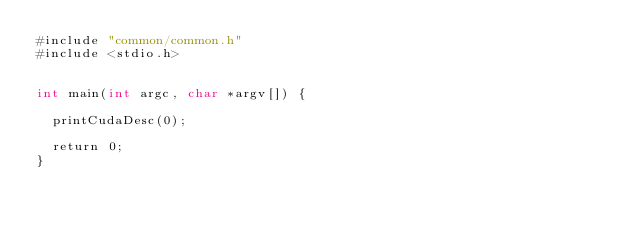Convert code to text. <code><loc_0><loc_0><loc_500><loc_500><_Cuda_>#include "common/common.h"
#include <stdio.h>


int main(int argc, char *argv[]) {

  printCudaDesc(0); 

  return 0;
}


</code> 